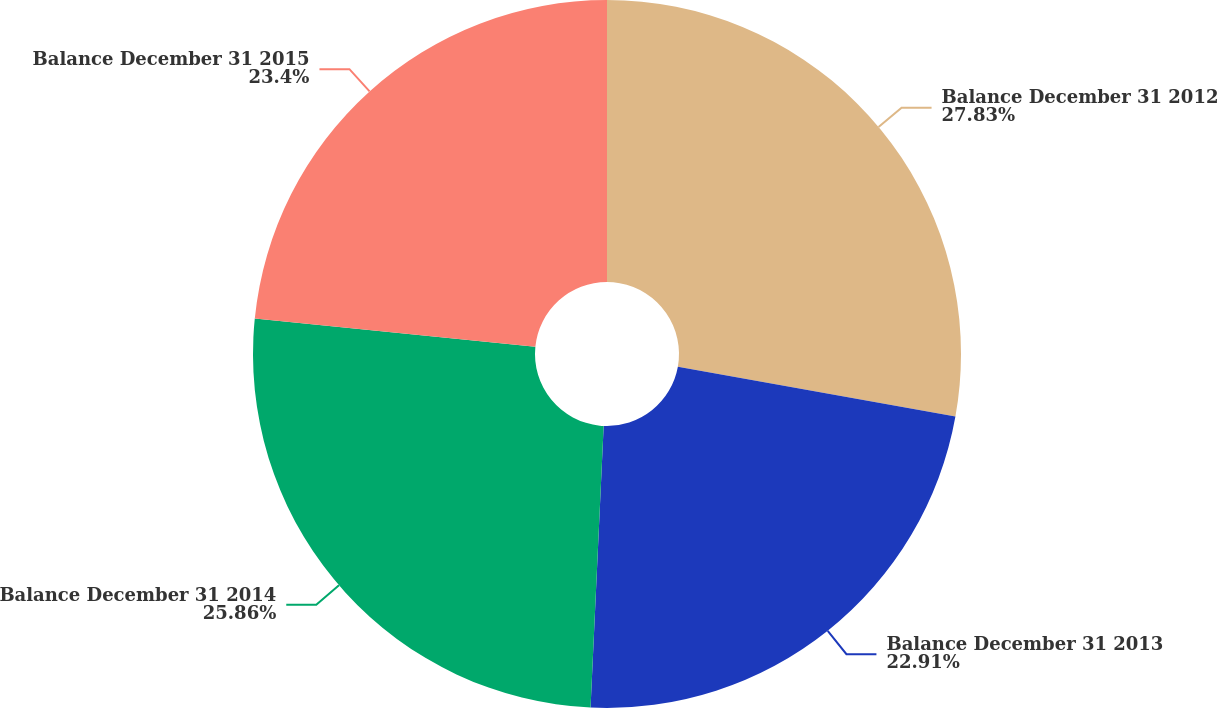<chart> <loc_0><loc_0><loc_500><loc_500><pie_chart><fcel>Balance December 31 2012<fcel>Balance December 31 2013<fcel>Balance December 31 2014<fcel>Balance December 31 2015<nl><fcel>27.83%<fcel>22.91%<fcel>25.86%<fcel>23.4%<nl></chart> 